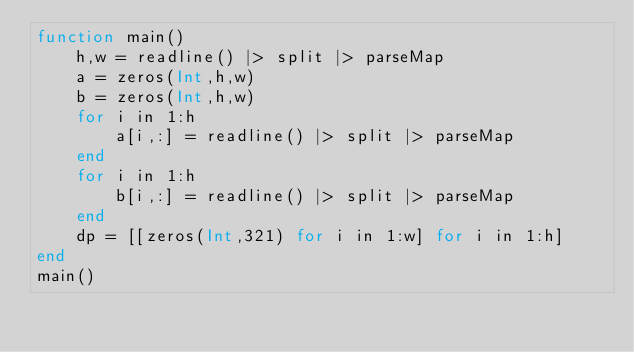Convert code to text. <code><loc_0><loc_0><loc_500><loc_500><_Julia_>function main()
	h,w = readline() |> split |> parseMap
	a = zeros(Int,h,w)
	b = zeros(Int,h,w)
	for i in 1:h
		a[i,:] = readline() |> split |> parseMap
	end
	for i in 1:h
		b[i,:] = readline() |> split |> parseMap
	end
	dp = [[zeros(Int,321) for i in 1:w] for i in 1:h]
end
main()</code> 